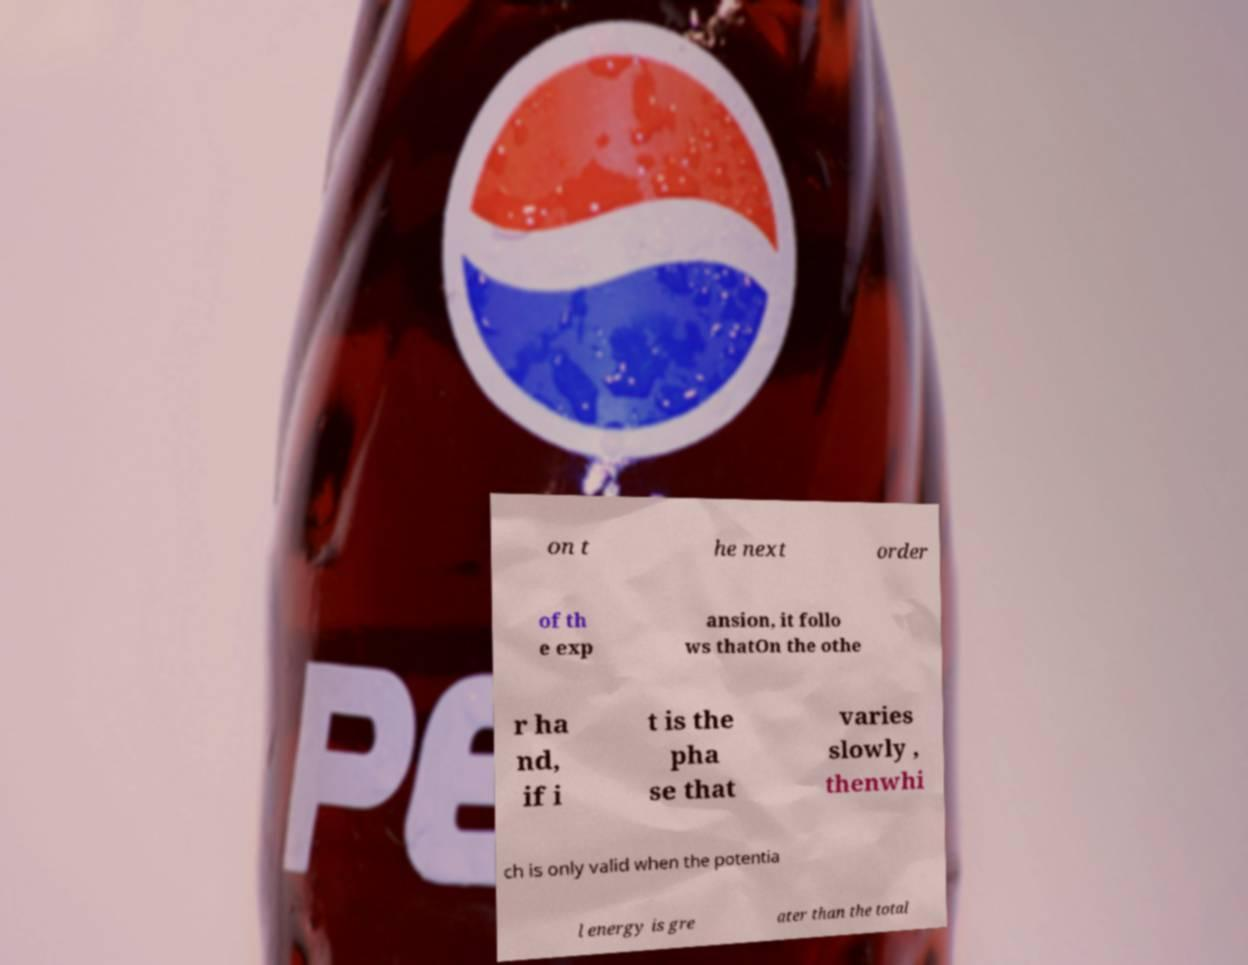Can you read and provide the text displayed in the image?This photo seems to have some interesting text. Can you extract and type it out for me? on t he next order of th e exp ansion, it follo ws thatOn the othe r ha nd, if i t is the pha se that varies slowly , thenwhi ch is only valid when the potentia l energy is gre ater than the total 